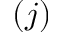Convert formula to latex. <formula><loc_0><loc_0><loc_500><loc_500>( j )</formula> 